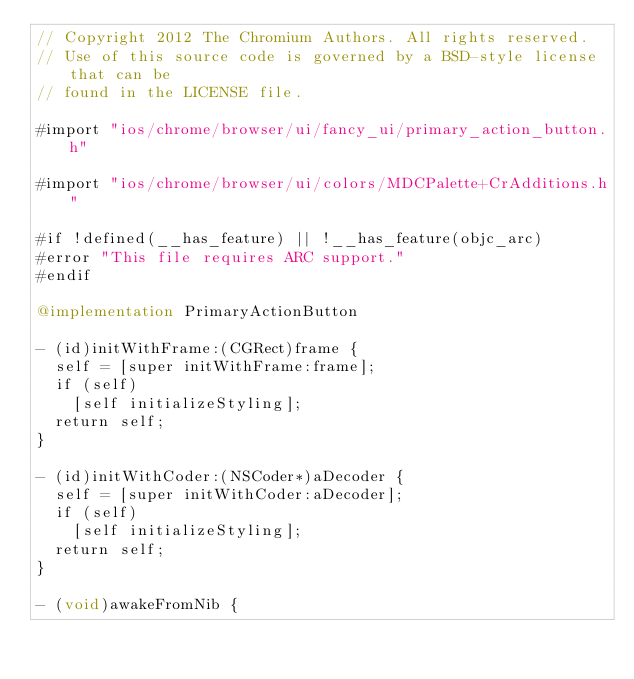Convert code to text. <code><loc_0><loc_0><loc_500><loc_500><_ObjectiveC_>// Copyright 2012 The Chromium Authors. All rights reserved.
// Use of this source code is governed by a BSD-style license that can be
// found in the LICENSE file.

#import "ios/chrome/browser/ui/fancy_ui/primary_action_button.h"

#import "ios/chrome/browser/ui/colors/MDCPalette+CrAdditions.h"

#if !defined(__has_feature) || !__has_feature(objc_arc)
#error "This file requires ARC support."
#endif

@implementation PrimaryActionButton

- (id)initWithFrame:(CGRect)frame {
  self = [super initWithFrame:frame];
  if (self)
    [self initializeStyling];
  return self;
}

- (id)initWithCoder:(NSCoder*)aDecoder {
  self = [super initWithCoder:aDecoder];
  if (self)
    [self initializeStyling];
  return self;
}

- (void)awakeFromNib {</code> 